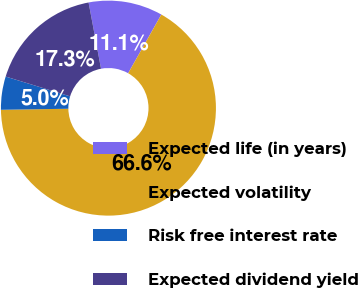Convert chart. <chart><loc_0><loc_0><loc_500><loc_500><pie_chart><fcel>Expected life (in years)<fcel>Expected volatility<fcel>Risk free interest rate<fcel>Expected dividend yield<nl><fcel>11.15%<fcel>66.56%<fcel>4.99%<fcel>17.3%<nl></chart> 